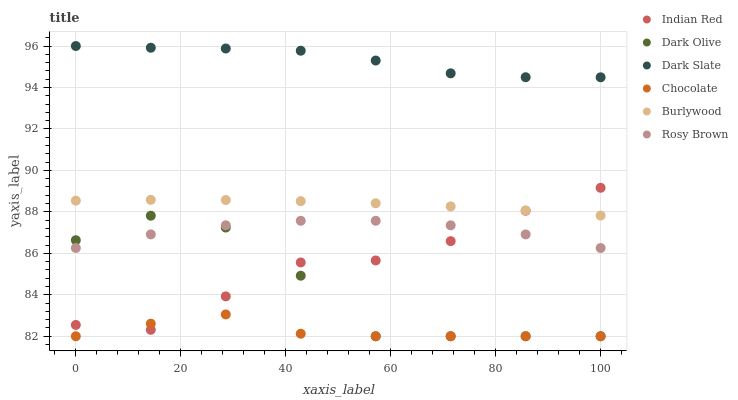Does Chocolate have the minimum area under the curve?
Answer yes or no. Yes. Does Dark Slate have the maximum area under the curve?
Answer yes or no. Yes. Does Burlywood have the minimum area under the curve?
Answer yes or no. No. Does Burlywood have the maximum area under the curve?
Answer yes or no. No. Is Burlywood the smoothest?
Answer yes or no. Yes. Is Dark Olive the roughest?
Answer yes or no. Yes. Is Rosy Brown the smoothest?
Answer yes or no. No. Is Rosy Brown the roughest?
Answer yes or no. No. Does Dark Olive have the lowest value?
Answer yes or no. Yes. Does Burlywood have the lowest value?
Answer yes or no. No. Does Dark Slate have the highest value?
Answer yes or no. Yes. Does Burlywood have the highest value?
Answer yes or no. No. Is Dark Olive less than Burlywood?
Answer yes or no. Yes. Is Dark Slate greater than Burlywood?
Answer yes or no. Yes. Does Chocolate intersect Dark Olive?
Answer yes or no. Yes. Is Chocolate less than Dark Olive?
Answer yes or no. No. Is Chocolate greater than Dark Olive?
Answer yes or no. No. Does Dark Olive intersect Burlywood?
Answer yes or no. No. 